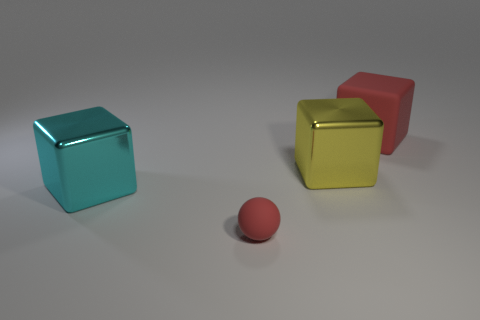Is there anything else that has the same shape as the tiny red thing?
Keep it short and to the point. No. Is there any other thing that is the same size as the sphere?
Make the answer very short. No. Are there any tiny things on the left side of the metal thing that is on the left side of the yellow shiny object?
Keep it short and to the point. No. There is a big thing that is the same material as the cyan block; what is its shape?
Provide a succinct answer. Cube. The red thing that is on the left side of the rubber object behind the big yellow block is made of what material?
Offer a very short reply. Rubber. Are there any other yellow objects that have the same shape as the big rubber thing?
Offer a very short reply. Yes. How many other objects are the same shape as the large rubber thing?
Keep it short and to the point. 2. There is a object that is both behind the small red matte thing and in front of the large yellow metal block; what is its shape?
Ensure brevity in your answer.  Cube. There is a matte thing that is in front of the big cyan cube; what is its size?
Your answer should be very brief. Small. Do the yellow cube and the rubber sphere have the same size?
Make the answer very short. No. 